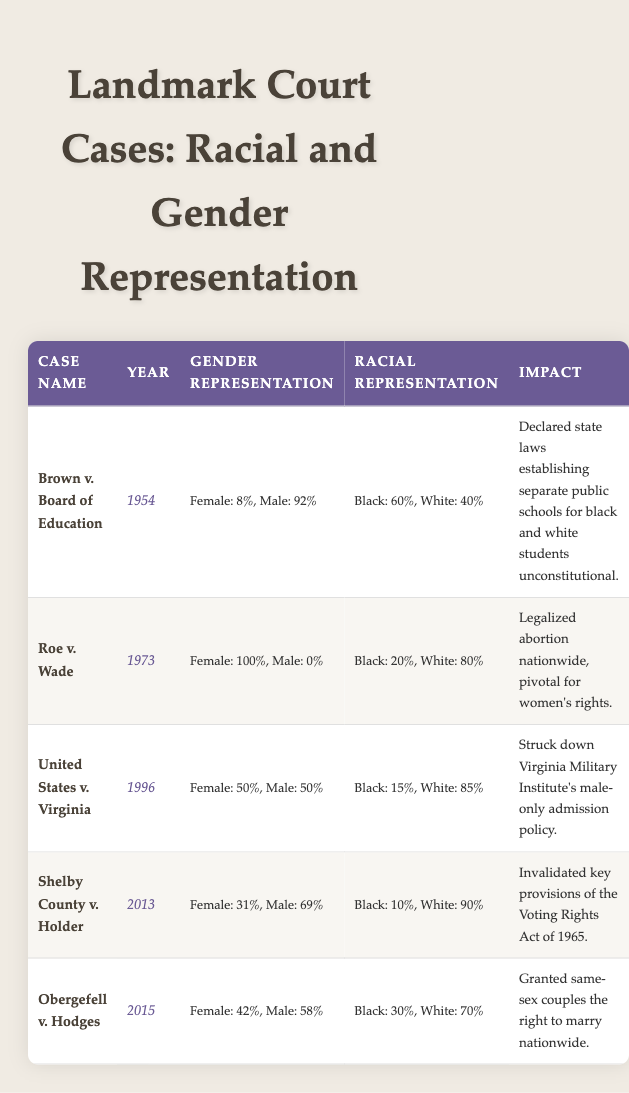What is the year of the Brown v. Board of Education case? The table lists the year next to the case name for each entry. For Brown v. Board of Education, the year provided is 1954.
Answer: 1954 What percentage of representation was male in the Roe v. Wade case? By checking the gender representation column for Roe v. Wade, it shows that the male representation is 0.00.
Answer: 0% Which case had the highest percentage of female representation? The table shows the gender representation for each case. Roe v. Wade has a female representation of 1.00, which is the highest compared to the other cases.
Answer: Roe v. Wade What is the average percentage of Black representation across all cases? To find the average percentage of Black representation, add the percentages: 60% + 20% + 15% + 10% + 30% = 135%. There are 5 cases, so the average is 135% / 5 = 27%.
Answer: 27% Is it true that the Shelby County v. Holder case has more male representation than female representation? Checking the gender representation for Shelby County v. Holder shows 69% male and 31% female, confirming that there is more male representation.
Answer: True In which cases is the white representation greater than 75%? By looking through the racial representation column, United States v. Virginia (85%) and Shelby County v. Holder (90%) both have white representation greater than 75%.
Answer: United States v. Virginia, Shelby County v. Holder What was the change in Black representation from Brown v. Board of Education to Obergefell v. Hodges? Black representation for Brown v. Board of Education is 60% and for Obergefell v. Hodges, it is 30%. The change is calculated as 60% - 30% = 30%.
Answer: 30% What percentage of the cases had a male representation of 50% or more? Looking at the gender representation, 3 out of the 5 cases had male representation of 50% or more: Brown v. Board of Education (92%), United States v. Virginia (50%), and Shelby County v. Holder (69%). 3 out of 5 is 60%.
Answer: 60% Was the impact of the Obergefell v. Hodges case related to same-sex marriage? The impact listed for Obergefell v. Hodges states that it granted same-sex couples the right to marry nationwide, confirming that the impact is related to same-sex marriage.
Answer: Yes 